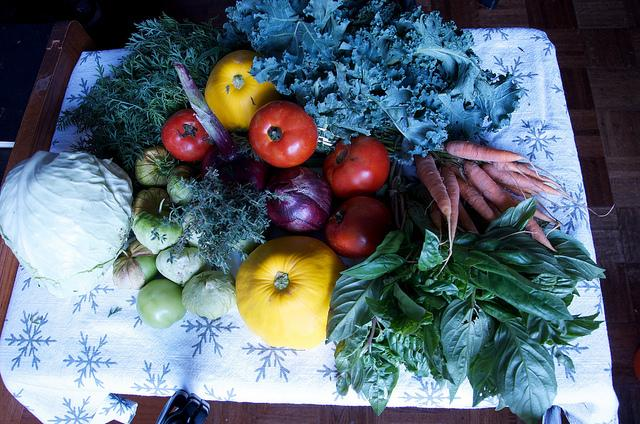What is the large vegetable on the far left? cabbage 